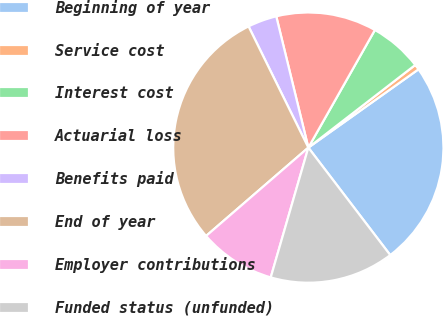Convert chart to OTSL. <chart><loc_0><loc_0><loc_500><loc_500><pie_chart><fcel>Beginning of year<fcel>Service cost<fcel>Interest cost<fcel>Actuarial loss<fcel>Benefits paid<fcel>End of year<fcel>Employer contributions<fcel>Funded status (unfunded)<nl><fcel>24.47%<fcel>0.64%<fcel>6.33%<fcel>12.01%<fcel>3.48%<fcel>29.05%<fcel>9.17%<fcel>14.85%<nl></chart> 